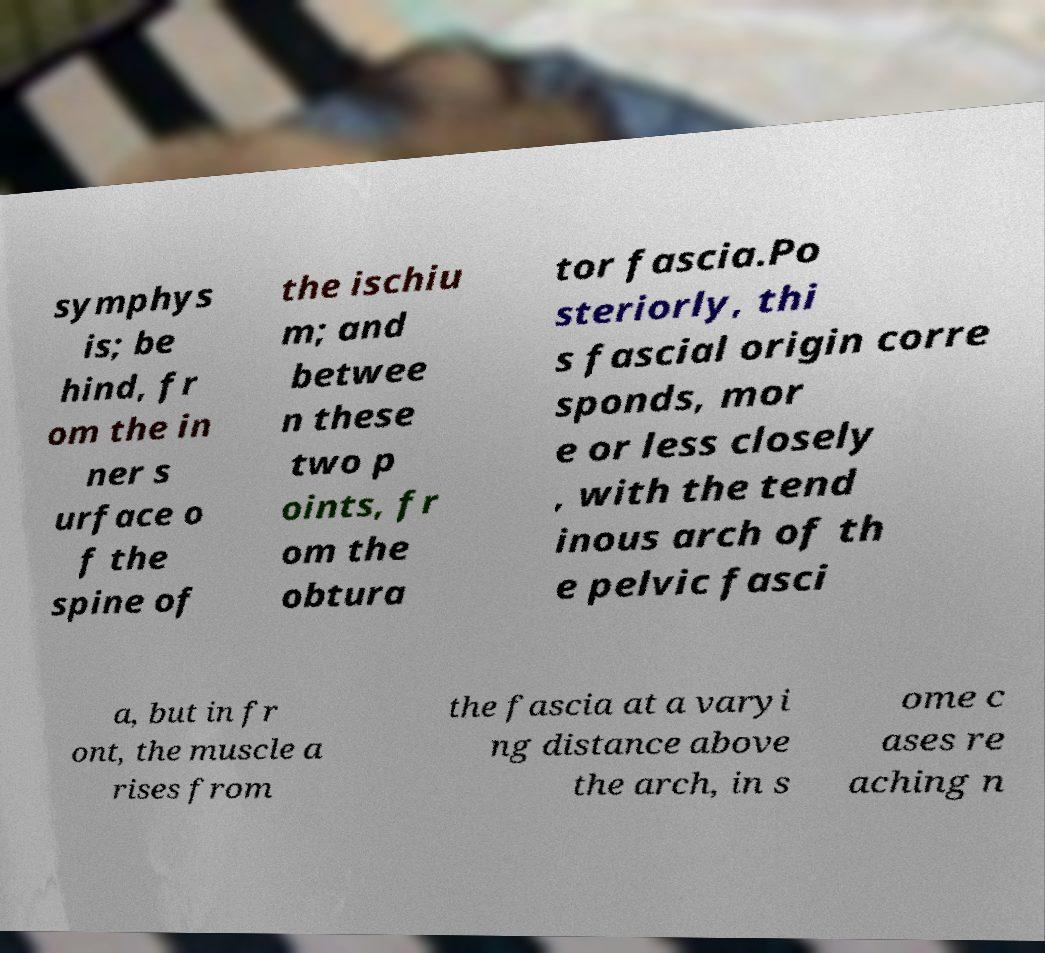For documentation purposes, I need the text within this image transcribed. Could you provide that? symphys is; be hind, fr om the in ner s urface o f the spine of the ischiu m; and betwee n these two p oints, fr om the obtura tor fascia.Po steriorly, thi s fascial origin corre sponds, mor e or less closely , with the tend inous arch of th e pelvic fasci a, but in fr ont, the muscle a rises from the fascia at a varyi ng distance above the arch, in s ome c ases re aching n 